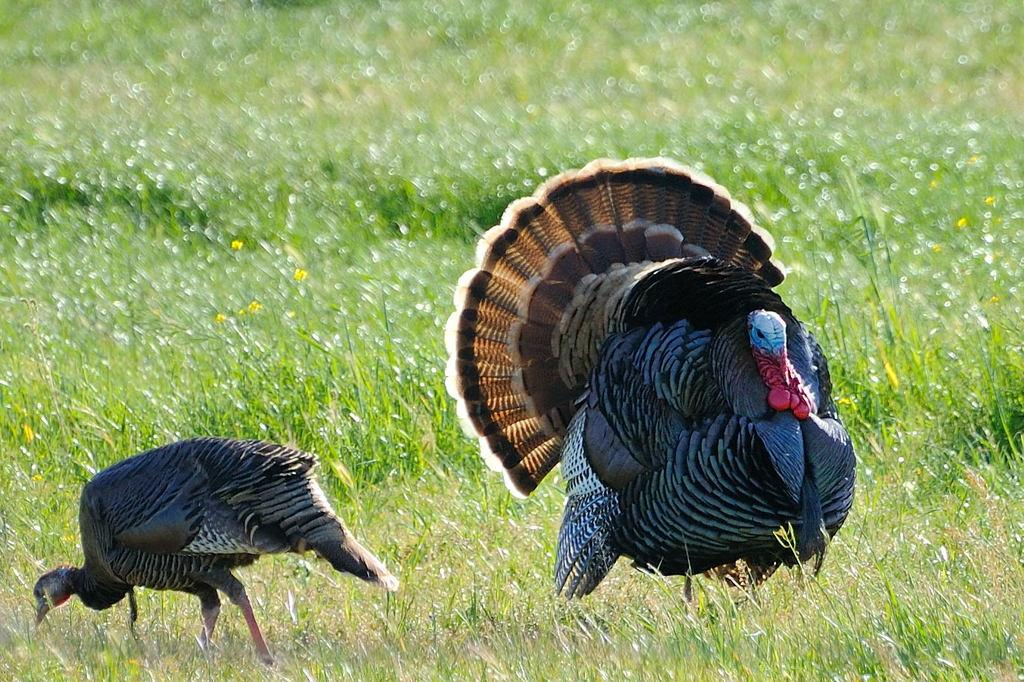What type of animals can be seen in the image? There are wild turkeys in the image. Where are the wild turkeys located? The wild turkeys are on the grass. What can be seen in the background of the image? There is a blurred background in the image, and plants and flowers are visible. What type of grape is being used as a prop by the wild turkeys in the image? There is no grape present in the image; the wild turkeys are on the grass and surrounded by a blurred background with plants and flowers. 